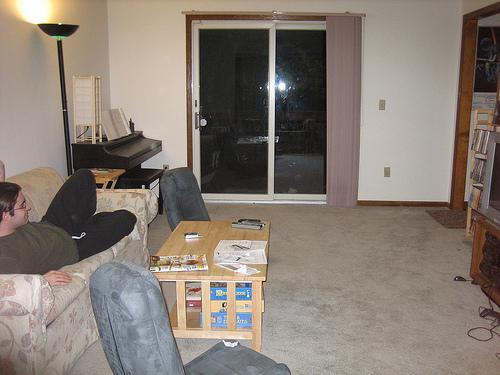Question: who is on the couch?
Choices:
A. A woman.
B. A baby.
C. A man.
D. A cat.
Answer with the letter. Answer: C Question: when was this photo taken?
Choices:
A. Evening.
B. At night.
C. Winter.
D. Morning.
Answer with the letter. Answer: B Question: what color are the curtains?
Choices:
A. Pink.
B. Orange.
C. Purple.
D. White.
Answer with the letter. Answer: C Question: why is this room illuminated?
Choices:
A. Sublight.
B. Lights on.
C. Window open.
D. The lamp.
Answer with the letter. Answer: D 